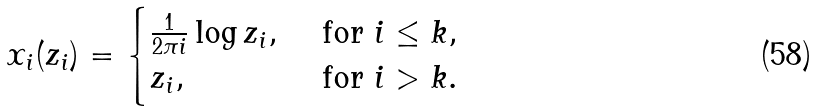Convert formula to latex. <formula><loc_0><loc_0><loc_500><loc_500>x _ { i } ( z _ { i } ) = \begin{cases} \frac { 1 } { 2 \pi i } \log z _ { i } , \ & \text {for } i \leq k , \\ z _ { i } , \ & \text {for } i > k . \end{cases}</formula> 